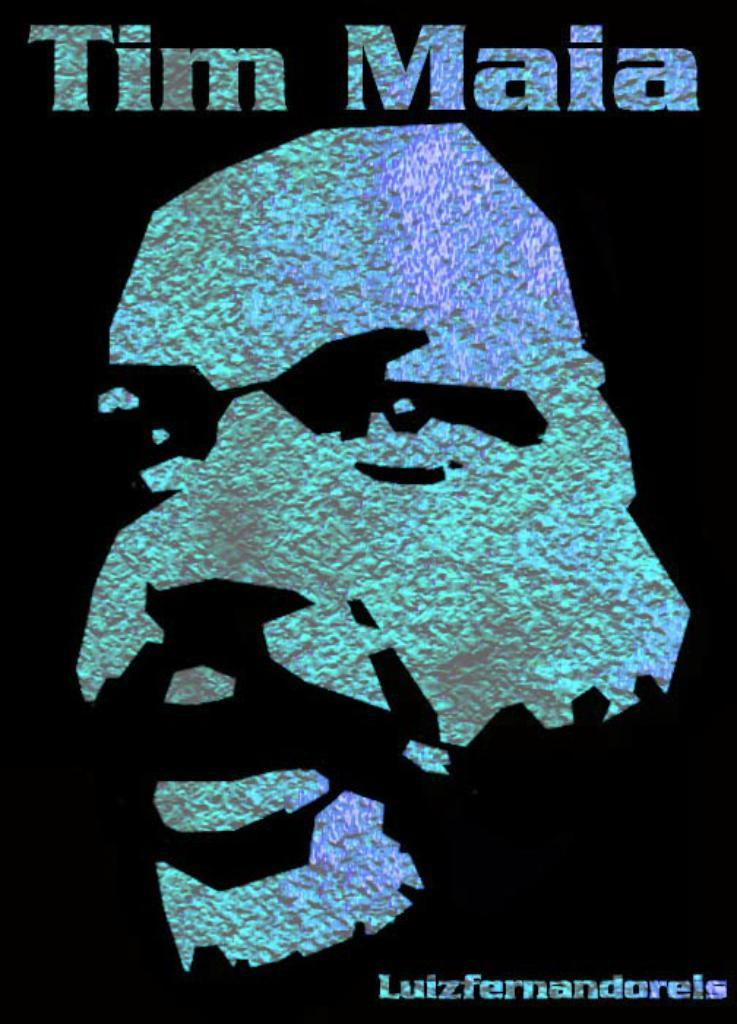<image>
Create a compact narrative representing the image presented. a blue and black poster that has Tim Maia on it 